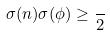Convert formula to latex. <formula><loc_0><loc_0><loc_500><loc_500>\sigma ( n ) \sigma ( \phi ) \geq \frac { } { 2 }</formula> 